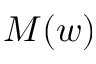Convert formula to latex. <formula><loc_0><loc_0><loc_500><loc_500>M ( w )</formula> 